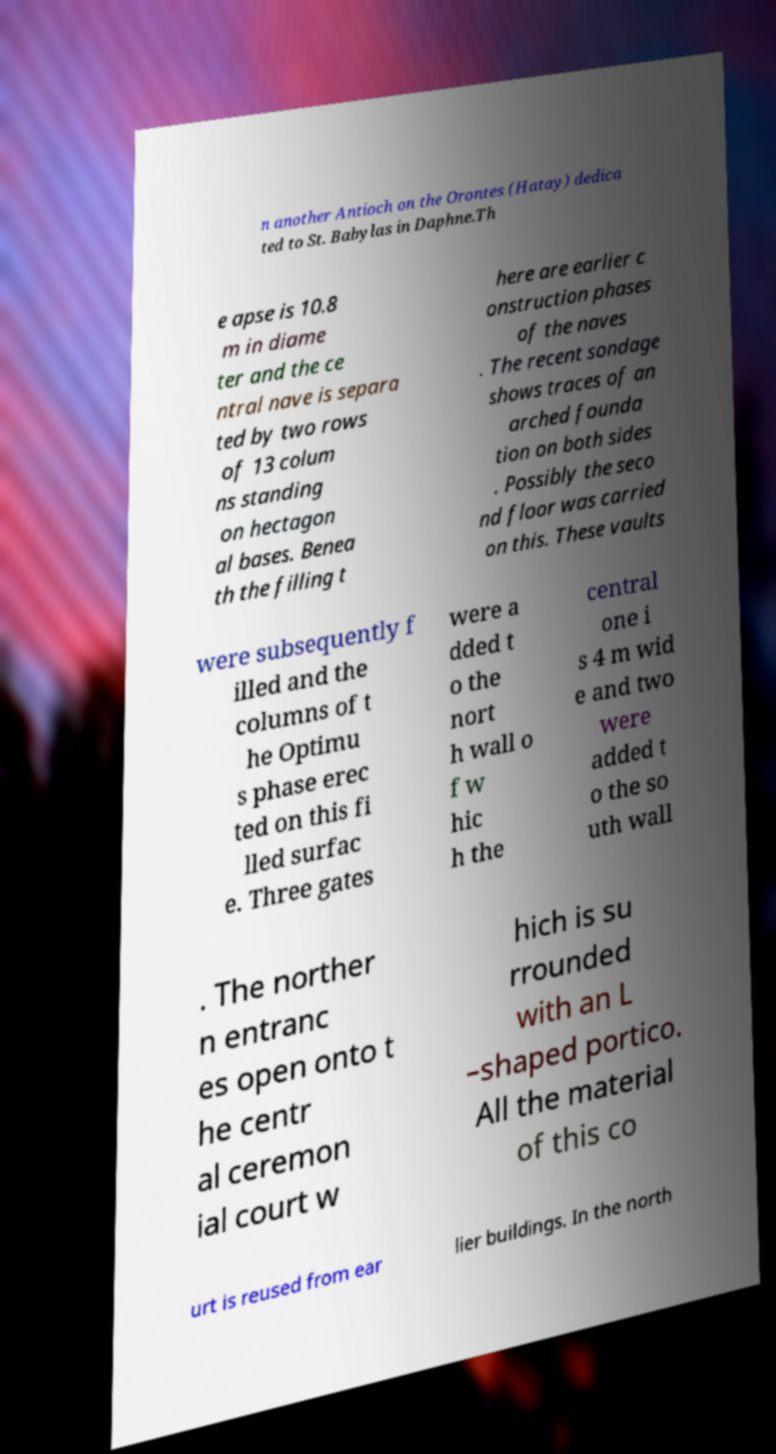Please read and relay the text visible in this image. What does it say? n another Antioch on the Orontes (Hatay) dedica ted to St. Babylas in Daphne.Th e apse is 10.8 m in diame ter and the ce ntral nave is separa ted by two rows of 13 colum ns standing on hectagon al bases. Benea th the filling t here are earlier c onstruction phases of the naves . The recent sondage shows traces of an arched founda tion on both sides . Possibly the seco nd floor was carried on this. These vaults were subsequently f illed and the columns of t he Optimu s phase erec ted on this fi lled surfac e. Three gates were a dded t o the nort h wall o f w hic h the central one i s 4 m wid e and two were added t o the so uth wall . The norther n entranc es open onto t he centr al ceremon ial court w hich is su rrounded with an L –shaped portico. All the material of this co urt is reused from ear lier buildings. In the north 